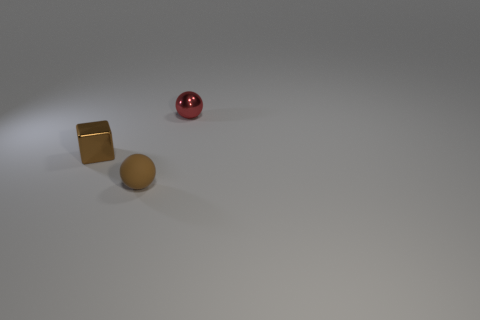Are there more red objects on the left side of the red metallic object than red metal objects in front of the metallic block? Upon examining the image, there is one red metallic spherical object and no additional red objects on the left side of it. Therefore, it is accurate to say that there are not more red objects on the left side than red metallic objects in front of the metallic block, as the red spherical object appears to be the only red object in the scene. 